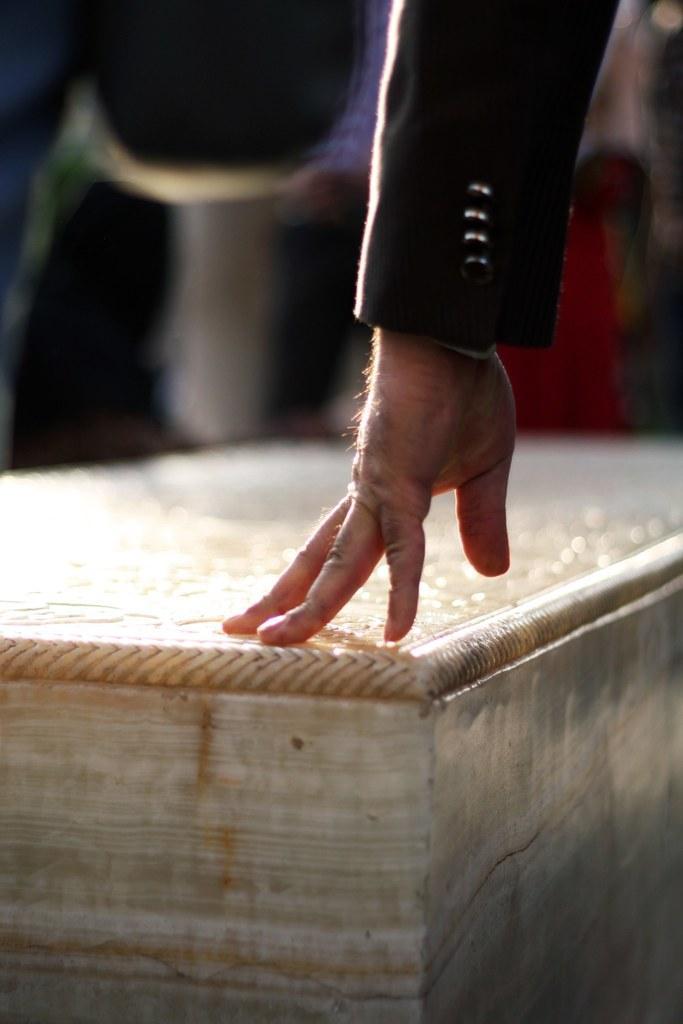Please provide a concise description of this image. In the front of the image I can see a person hand is on the wooden object. In the background of the image it is blurry. 